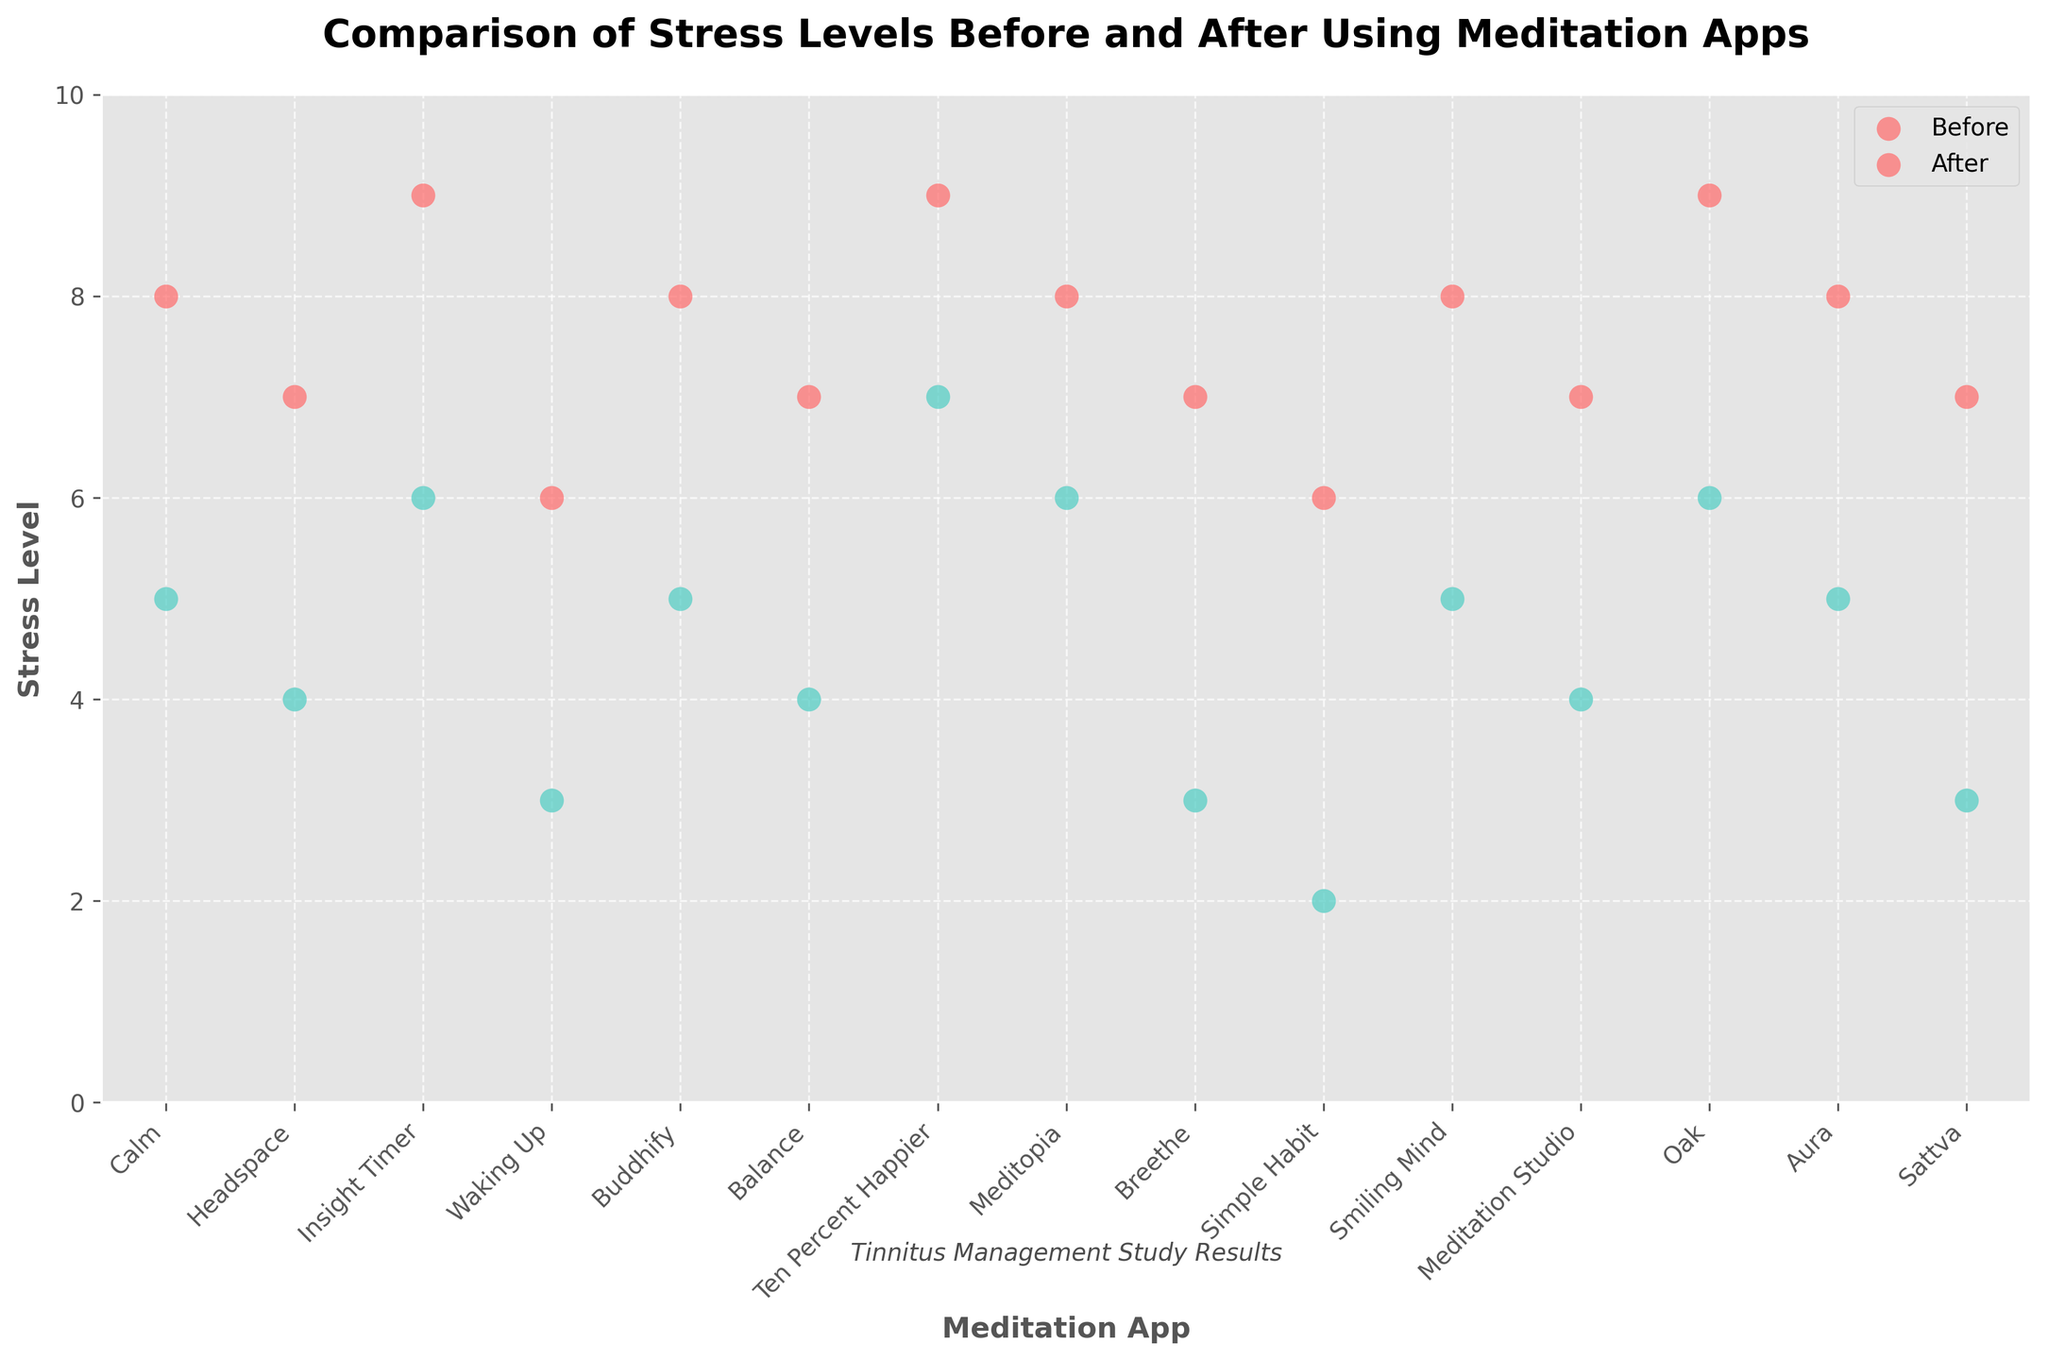What's the title of the figure? The title is typically displayed at the top of the figure in a bold and larger font. Here, it says "Comparison of Stress Levels Before and After Using Meditation Apps."
Answer: Comparison of Stress Levels Before and After Using Meditation Apps What colors represent the stress levels before and after using the meditation apps? The legend in the upper right of the figure shows the colors attributed to each condition: stress levels before are marked in red, and after are in green.
Answer: Red and green Which meditation app shows the highest stress level after use? By looking at the highest point of each green dot grouping for "Stress Level After" in the strip plot, we see that the highest green dot is for the app "Ten Percent Happier," which has a stress level of 7.
Answer: Ten Percent Happier How many meditation apps are included in the study? By counting the unique categories on the x-axis, we can see that there are 15 different meditation apps listed.
Answer: 15 What is the median stress level before using the meditation apps? We need to find the middle value of the "Stress Level Before" data points. Listing them from lowest to highest (6, 6, 7, 7, 7, 7, 7, 8, 8, 8, 8, 8, 9, 9, 9), the median value is the 8th value in the ordered list, which is 8.
Answer: 8 Does any user have the same stress level before and after using the app? By comparing the red and green dots for each user, no overlapping values suggest no user has the same stress level before and after using the meditation app.
Answer: No What is the average reduction in stress level across all users? Calculate the reduction for each user and then average them. The reductions are 3, 3, 3, 3, 3, 3, 2, 2, 4, 4, 3, 3, 3, 3, 4. Summing these reductions gives 43, and dividing by 15 users, the average reduction is 2.87.
Answer: 2.87 Which meditation app shows the greatest reduction in stress levels? To find the greatest reduction, we compare the difference between before and after for each app. "Simple Habit" shows the largest reduction, from 6 to 2, which is 4.
Answer: Simple Habit 